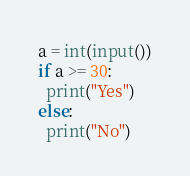<code> <loc_0><loc_0><loc_500><loc_500><_Python_>a = int(input())
if a >= 30:
  print("Yes")
else:
  print("No")</code> 